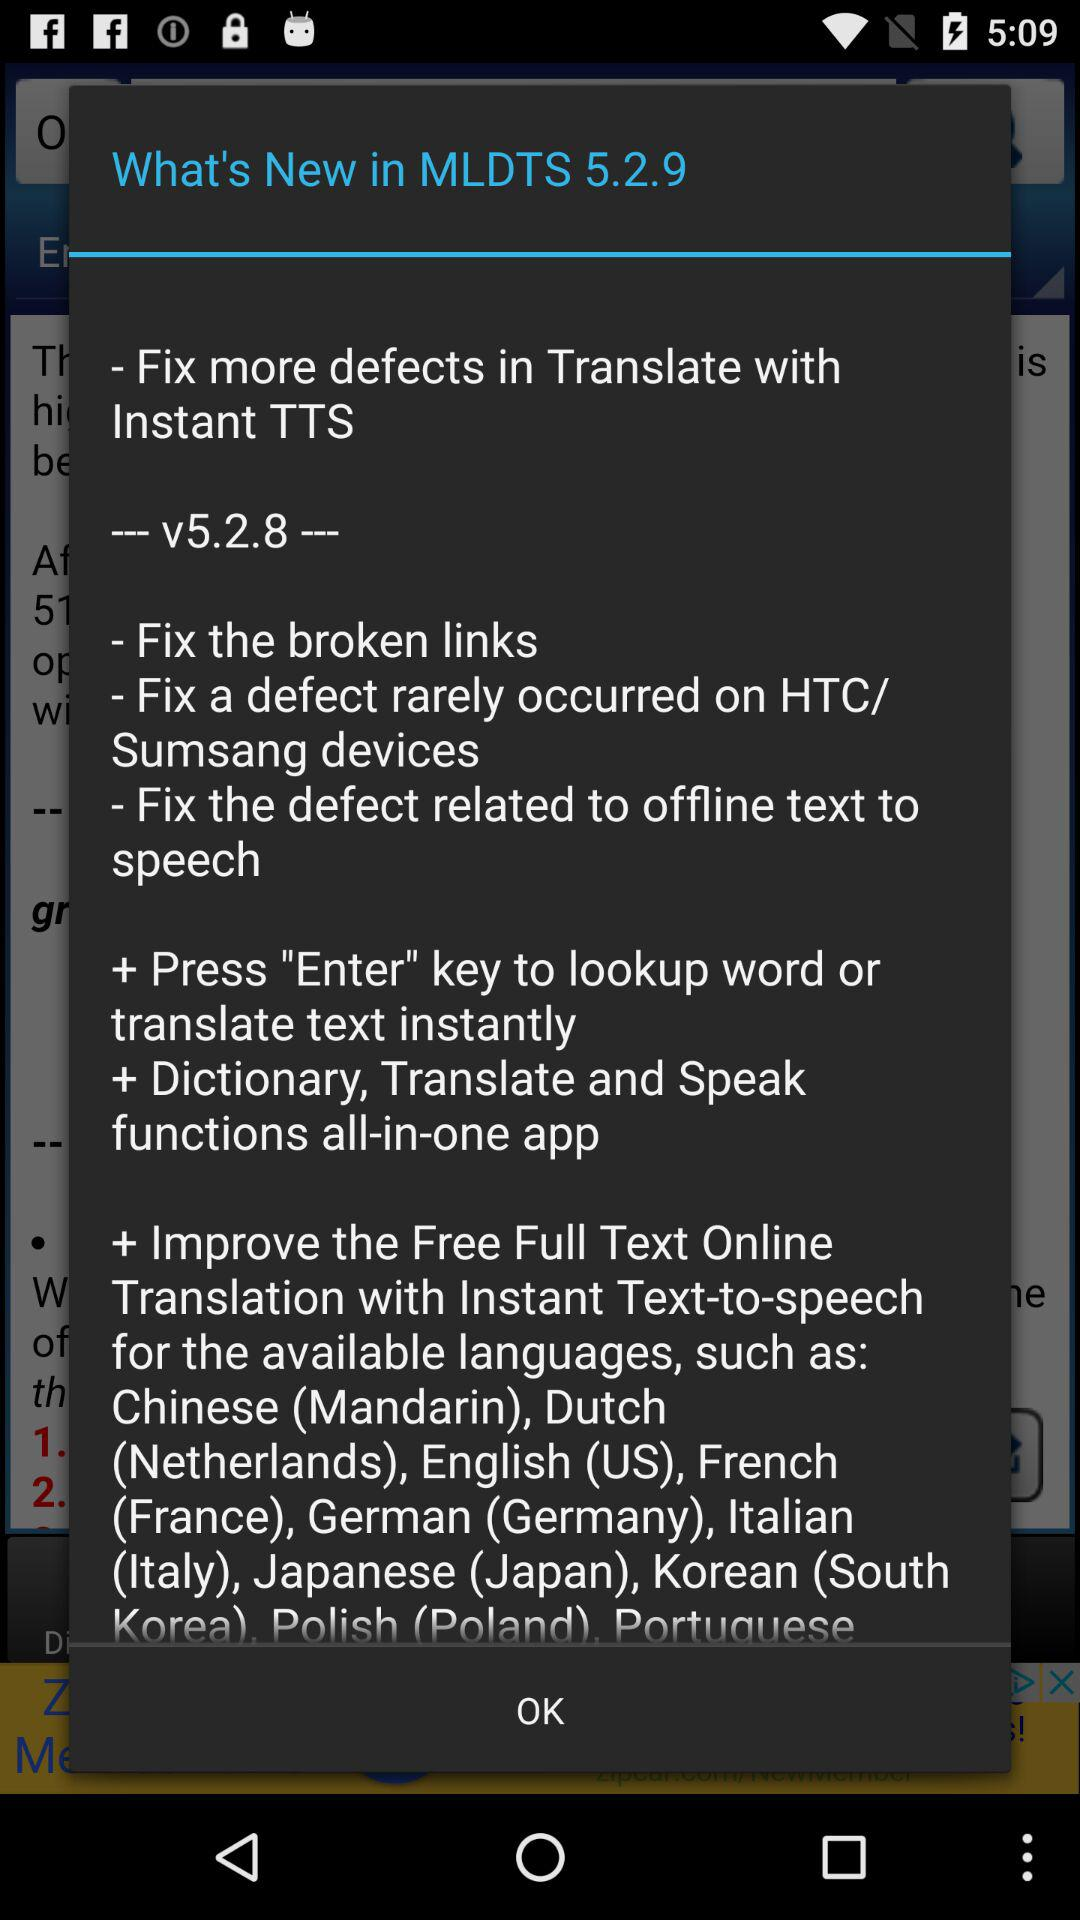What is new in MLDTS 5.2.9? In MLDTS 5.2.9, "Fix more defects in Translate with Instant TTS" is new. 